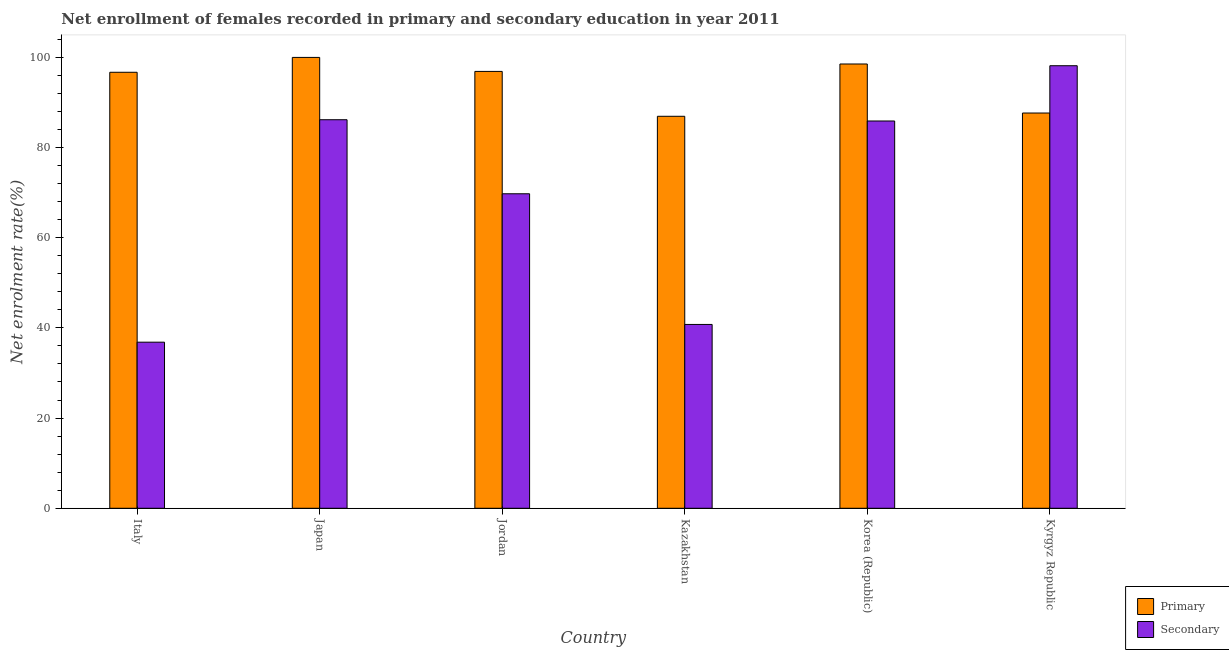Are the number of bars on each tick of the X-axis equal?
Offer a very short reply. Yes. How many bars are there on the 3rd tick from the left?
Provide a succinct answer. 2. What is the label of the 3rd group of bars from the left?
Your response must be concise. Jordan. In how many cases, is the number of bars for a given country not equal to the number of legend labels?
Keep it short and to the point. 0. What is the enrollment rate in secondary education in Japan?
Your answer should be compact. 86.14. Across all countries, what is the maximum enrollment rate in primary education?
Provide a succinct answer. 99.95. Across all countries, what is the minimum enrollment rate in secondary education?
Provide a succinct answer. 36.82. In which country was the enrollment rate in primary education maximum?
Provide a succinct answer. Japan. In which country was the enrollment rate in primary education minimum?
Your answer should be compact. Kazakhstan. What is the total enrollment rate in primary education in the graph?
Provide a short and direct response. 566.46. What is the difference between the enrollment rate in primary education in Japan and that in Kyrgyz Republic?
Offer a very short reply. 12.33. What is the difference between the enrollment rate in primary education in Italy and the enrollment rate in secondary education in Korea (Republic)?
Offer a terse response. 10.8. What is the average enrollment rate in secondary education per country?
Give a very brief answer. 69.57. What is the difference between the enrollment rate in primary education and enrollment rate in secondary education in Jordan?
Offer a very short reply. 27.12. What is the ratio of the enrollment rate in primary education in Italy to that in Jordan?
Offer a very short reply. 1. What is the difference between the highest and the second highest enrollment rate in secondary education?
Offer a very short reply. 11.97. What is the difference between the highest and the lowest enrollment rate in secondary education?
Give a very brief answer. 61.29. In how many countries, is the enrollment rate in primary education greater than the average enrollment rate in primary education taken over all countries?
Offer a very short reply. 4. What does the 2nd bar from the left in Kazakhstan represents?
Your answer should be very brief. Secondary. What does the 2nd bar from the right in Italy represents?
Your answer should be very brief. Primary. How many bars are there?
Offer a very short reply. 12. What is the difference between two consecutive major ticks on the Y-axis?
Give a very brief answer. 20. Where does the legend appear in the graph?
Your answer should be very brief. Bottom right. How many legend labels are there?
Your answer should be very brief. 2. How are the legend labels stacked?
Your response must be concise. Vertical. What is the title of the graph?
Make the answer very short. Net enrollment of females recorded in primary and secondary education in year 2011. Does "Primary income" appear as one of the legend labels in the graph?
Offer a very short reply. No. What is the label or title of the X-axis?
Make the answer very short. Country. What is the label or title of the Y-axis?
Your answer should be very brief. Net enrolment rate(%). What is the Net enrolment rate(%) in Primary in Italy?
Your response must be concise. 96.66. What is the Net enrolment rate(%) in Secondary in Italy?
Keep it short and to the point. 36.82. What is the Net enrolment rate(%) of Primary in Japan?
Provide a succinct answer. 99.95. What is the Net enrolment rate(%) in Secondary in Japan?
Your response must be concise. 86.14. What is the Net enrolment rate(%) of Primary in Jordan?
Keep it short and to the point. 96.85. What is the Net enrolment rate(%) of Secondary in Jordan?
Offer a very short reply. 69.72. What is the Net enrolment rate(%) of Primary in Kazakhstan?
Your response must be concise. 86.9. What is the Net enrolment rate(%) in Secondary in Kazakhstan?
Provide a succinct answer. 40.75. What is the Net enrolment rate(%) of Primary in Korea (Republic)?
Your response must be concise. 98.49. What is the Net enrolment rate(%) in Secondary in Korea (Republic)?
Provide a succinct answer. 85.86. What is the Net enrolment rate(%) of Primary in Kyrgyz Republic?
Offer a very short reply. 87.62. What is the Net enrolment rate(%) in Secondary in Kyrgyz Republic?
Give a very brief answer. 98.11. Across all countries, what is the maximum Net enrolment rate(%) in Primary?
Offer a very short reply. 99.95. Across all countries, what is the maximum Net enrolment rate(%) in Secondary?
Your answer should be compact. 98.11. Across all countries, what is the minimum Net enrolment rate(%) in Primary?
Your answer should be compact. 86.9. Across all countries, what is the minimum Net enrolment rate(%) in Secondary?
Your answer should be compact. 36.82. What is the total Net enrolment rate(%) in Primary in the graph?
Your answer should be very brief. 566.46. What is the total Net enrolment rate(%) of Secondary in the graph?
Offer a very short reply. 417.4. What is the difference between the Net enrolment rate(%) in Primary in Italy and that in Japan?
Your response must be concise. -3.29. What is the difference between the Net enrolment rate(%) in Secondary in Italy and that in Japan?
Provide a short and direct response. -49.32. What is the difference between the Net enrolment rate(%) in Primary in Italy and that in Jordan?
Provide a short and direct response. -0.19. What is the difference between the Net enrolment rate(%) of Secondary in Italy and that in Jordan?
Ensure brevity in your answer.  -32.9. What is the difference between the Net enrolment rate(%) of Primary in Italy and that in Kazakhstan?
Keep it short and to the point. 9.76. What is the difference between the Net enrolment rate(%) in Secondary in Italy and that in Kazakhstan?
Keep it short and to the point. -3.93. What is the difference between the Net enrolment rate(%) in Primary in Italy and that in Korea (Republic)?
Your answer should be very brief. -1.83. What is the difference between the Net enrolment rate(%) of Secondary in Italy and that in Korea (Republic)?
Your answer should be compact. -49.04. What is the difference between the Net enrolment rate(%) of Primary in Italy and that in Kyrgyz Republic?
Offer a very short reply. 9.03. What is the difference between the Net enrolment rate(%) of Secondary in Italy and that in Kyrgyz Republic?
Offer a very short reply. -61.29. What is the difference between the Net enrolment rate(%) in Primary in Japan and that in Jordan?
Offer a very short reply. 3.1. What is the difference between the Net enrolment rate(%) of Secondary in Japan and that in Jordan?
Provide a succinct answer. 16.42. What is the difference between the Net enrolment rate(%) in Primary in Japan and that in Kazakhstan?
Your answer should be very brief. 13.05. What is the difference between the Net enrolment rate(%) in Secondary in Japan and that in Kazakhstan?
Your response must be concise. 45.38. What is the difference between the Net enrolment rate(%) in Primary in Japan and that in Korea (Republic)?
Keep it short and to the point. 1.46. What is the difference between the Net enrolment rate(%) of Secondary in Japan and that in Korea (Republic)?
Your response must be concise. 0.28. What is the difference between the Net enrolment rate(%) in Primary in Japan and that in Kyrgyz Republic?
Your answer should be very brief. 12.33. What is the difference between the Net enrolment rate(%) of Secondary in Japan and that in Kyrgyz Republic?
Offer a very short reply. -11.97. What is the difference between the Net enrolment rate(%) in Primary in Jordan and that in Kazakhstan?
Your answer should be very brief. 9.95. What is the difference between the Net enrolment rate(%) in Secondary in Jordan and that in Kazakhstan?
Keep it short and to the point. 28.97. What is the difference between the Net enrolment rate(%) of Primary in Jordan and that in Korea (Republic)?
Keep it short and to the point. -1.65. What is the difference between the Net enrolment rate(%) in Secondary in Jordan and that in Korea (Republic)?
Your answer should be compact. -16.14. What is the difference between the Net enrolment rate(%) in Primary in Jordan and that in Kyrgyz Republic?
Offer a very short reply. 9.22. What is the difference between the Net enrolment rate(%) of Secondary in Jordan and that in Kyrgyz Republic?
Offer a very short reply. -28.39. What is the difference between the Net enrolment rate(%) of Primary in Kazakhstan and that in Korea (Republic)?
Provide a succinct answer. -11.59. What is the difference between the Net enrolment rate(%) of Secondary in Kazakhstan and that in Korea (Republic)?
Keep it short and to the point. -45.1. What is the difference between the Net enrolment rate(%) in Primary in Kazakhstan and that in Kyrgyz Republic?
Your answer should be very brief. -0.73. What is the difference between the Net enrolment rate(%) of Secondary in Kazakhstan and that in Kyrgyz Republic?
Offer a very short reply. -57.36. What is the difference between the Net enrolment rate(%) in Primary in Korea (Republic) and that in Kyrgyz Republic?
Offer a very short reply. 10.87. What is the difference between the Net enrolment rate(%) of Secondary in Korea (Republic) and that in Kyrgyz Republic?
Provide a succinct answer. -12.25. What is the difference between the Net enrolment rate(%) in Primary in Italy and the Net enrolment rate(%) in Secondary in Japan?
Give a very brief answer. 10.52. What is the difference between the Net enrolment rate(%) of Primary in Italy and the Net enrolment rate(%) of Secondary in Jordan?
Offer a terse response. 26.93. What is the difference between the Net enrolment rate(%) of Primary in Italy and the Net enrolment rate(%) of Secondary in Kazakhstan?
Make the answer very short. 55.9. What is the difference between the Net enrolment rate(%) of Primary in Italy and the Net enrolment rate(%) of Secondary in Korea (Republic)?
Your answer should be compact. 10.8. What is the difference between the Net enrolment rate(%) of Primary in Italy and the Net enrolment rate(%) of Secondary in Kyrgyz Republic?
Your answer should be very brief. -1.45. What is the difference between the Net enrolment rate(%) in Primary in Japan and the Net enrolment rate(%) in Secondary in Jordan?
Provide a succinct answer. 30.23. What is the difference between the Net enrolment rate(%) of Primary in Japan and the Net enrolment rate(%) of Secondary in Kazakhstan?
Provide a succinct answer. 59.2. What is the difference between the Net enrolment rate(%) of Primary in Japan and the Net enrolment rate(%) of Secondary in Korea (Republic)?
Offer a terse response. 14.09. What is the difference between the Net enrolment rate(%) in Primary in Japan and the Net enrolment rate(%) in Secondary in Kyrgyz Republic?
Keep it short and to the point. 1.84. What is the difference between the Net enrolment rate(%) in Primary in Jordan and the Net enrolment rate(%) in Secondary in Kazakhstan?
Ensure brevity in your answer.  56.09. What is the difference between the Net enrolment rate(%) of Primary in Jordan and the Net enrolment rate(%) of Secondary in Korea (Republic)?
Offer a very short reply. 10.99. What is the difference between the Net enrolment rate(%) in Primary in Jordan and the Net enrolment rate(%) in Secondary in Kyrgyz Republic?
Your response must be concise. -1.26. What is the difference between the Net enrolment rate(%) in Primary in Kazakhstan and the Net enrolment rate(%) in Secondary in Korea (Republic)?
Offer a terse response. 1.04. What is the difference between the Net enrolment rate(%) of Primary in Kazakhstan and the Net enrolment rate(%) of Secondary in Kyrgyz Republic?
Your response must be concise. -11.21. What is the difference between the Net enrolment rate(%) in Primary in Korea (Republic) and the Net enrolment rate(%) in Secondary in Kyrgyz Republic?
Your answer should be very brief. 0.38. What is the average Net enrolment rate(%) of Primary per country?
Keep it short and to the point. 94.41. What is the average Net enrolment rate(%) of Secondary per country?
Offer a terse response. 69.57. What is the difference between the Net enrolment rate(%) in Primary and Net enrolment rate(%) in Secondary in Italy?
Your answer should be compact. 59.84. What is the difference between the Net enrolment rate(%) in Primary and Net enrolment rate(%) in Secondary in Japan?
Provide a succinct answer. 13.81. What is the difference between the Net enrolment rate(%) of Primary and Net enrolment rate(%) of Secondary in Jordan?
Make the answer very short. 27.12. What is the difference between the Net enrolment rate(%) in Primary and Net enrolment rate(%) in Secondary in Kazakhstan?
Give a very brief answer. 46.15. What is the difference between the Net enrolment rate(%) in Primary and Net enrolment rate(%) in Secondary in Korea (Republic)?
Your response must be concise. 12.63. What is the difference between the Net enrolment rate(%) of Primary and Net enrolment rate(%) of Secondary in Kyrgyz Republic?
Offer a very short reply. -10.48. What is the ratio of the Net enrolment rate(%) of Secondary in Italy to that in Japan?
Your answer should be compact. 0.43. What is the ratio of the Net enrolment rate(%) of Secondary in Italy to that in Jordan?
Offer a terse response. 0.53. What is the ratio of the Net enrolment rate(%) of Primary in Italy to that in Kazakhstan?
Your response must be concise. 1.11. What is the ratio of the Net enrolment rate(%) of Secondary in Italy to that in Kazakhstan?
Your answer should be compact. 0.9. What is the ratio of the Net enrolment rate(%) of Primary in Italy to that in Korea (Republic)?
Give a very brief answer. 0.98. What is the ratio of the Net enrolment rate(%) of Secondary in Italy to that in Korea (Republic)?
Your response must be concise. 0.43. What is the ratio of the Net enrolment rate(%) in Primary in Italy to that in Kyrgyz Republic?
Give a very brief answer. 1.1. What is the ratio of the Net enrolment rate(%) of Secondary in Italy to that in Kyrgyz Republic?
Your answer should be very brief. 0.38. What is the ratio of the Net enrolment rate(%) in Primary in Japan to that in Jordan?
Your response must be concise. 1.03. What is the ratio of the Net enrolment rate(%) of Secondary in Japan to that in Jordan?
Ensure brevity in your answer.  1.24. What is the ratio of the Net enrolment rate(%) in Primary in Japan to that in Kazakhstan?
Your response must be concise. 1.15. What is the ratio of the Net enrolment rate(%) of Secondary in Japan to that in Kazakhstan?
Offer a terse response. 2.11. What is the ratio of the Net enrolment rate(%) of Primary in Japan to that in Korea (Republic)?
Give a very brief answer. 1.01. What is the ratio of the Net enrolment rate(%) of Secondary in Japan to that in Korea (Republic)?
Provide a short and direct response. 1. What is the ratio of the Net enrolment rate(%) in Primary in Japan to that in Kyrgyz Republic?
Offer a terse response. 1.14. What is the ratio of the Net enrolment rate(%) of Secondary in Japan to that in Kyrgyz Republic?
Provide a short and direct response. 0.88. What is the ratio of the Net enrolment rate(%) in Primary in Jordan to that in Kazakhstan?
Give a very brief answer. 1.11. What is the ratio of the Net enrolment rate(%) in Secondary in Jordan to that in Kazakhstan?
Your response must be concise. 1.71. What is the ratio of the Net enrolment rate(%) of Primary in Jordan to that in Korea (Republic)?
Give a very brief answer. 0.98. What is the ratio of the Net enrolment rate(%) of Secondary in Jordan to that in Korea (Republic)?
Ensure brevity in your answer.  0.81. What is the ratio of the Net enrolment rate(%) in Primary in Jordan to that in Kyrgyz Republic?
Your response must be concise. 1.11. What is the ratio of the Net enrolment rate(%) in Secondary in Jordan to that in Kyrgyz Republic?
Give a very brief answer. 0.71. What is the ratio of the Net enrolment rate(%) in Primary in Kazakhstan to that in Korea (Republic)?
Make the answer very short. 0.88. What is the ratio of the Net enrolment rate(%) in Secondary in Kazakhstan to that in Korea (Republic)?
Your answer should be very brief. 0.47. What is the ratio of the Net enrolment rate(%) in Primary in Kazakhstan to that in Kyrgyz Republic?
Provide a succinct answer. 0.99. What is the ratio of the Net enrolment rate(%) of Secondary in Kazakhstan to that in Kyrgyz Republic?
Provide a succinct answer. 0.42. What is the ratio of the Net enrolment rate(%) of Primary in Korea (Republic) to that in Kyrgyz Republic?
Offer a terse response. 1.12. What is the ratio of the Net enrolment rate(%) in Secondary in Korea (Republic) to that in Kyrgyz Republic?
Ensure brevity in your answer.  0.88. What is the difference between the highest and the second highest Net enrolment rate(%) of Primary?
Your answer should be compact. 1.46. What is the difference between the highest and the second highest Net enrolment rate(%) in Secondary?
Keep it short and to the point. 11.97. What is the difference between the highest and the lowest Net enrolment rate(%) of Primary?
Your response must be concise. 13.05. What is the difference between the highest and the lowest Net enrolment rate(%) in Secondary?
Provide a succinct answer. 61.29. 